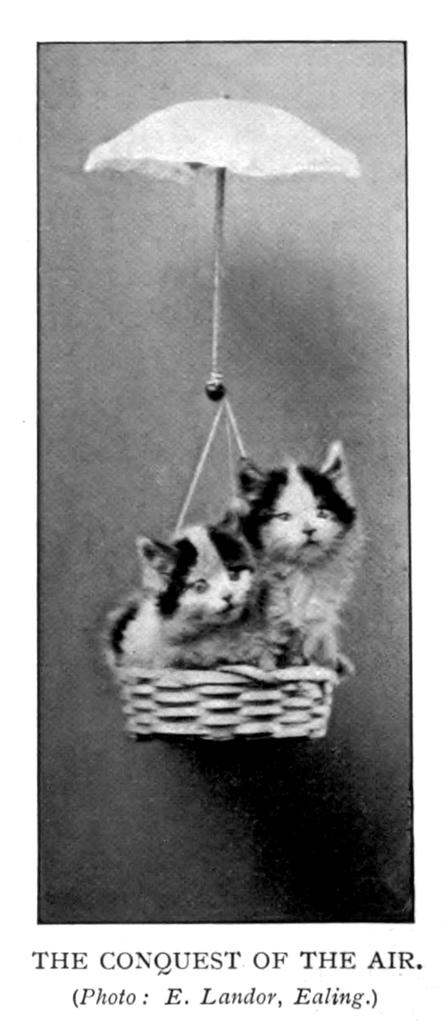What animals can be seen in the foreground of the poster? There are two cats in a basket in the foreground of the poster. What object is visible at the top of the poster? There is an umbrella at the top of the poster. What can be found at the bottom of the poster? There is some text at the bottom of the poster. What type of test is being conducted with the cats in the poster? There is no test being conducted in the poster; it simply features two cats in a basket. What kind of jewel can be seen on the cats in the poster? There are no jewels present on the cats in the poster. 